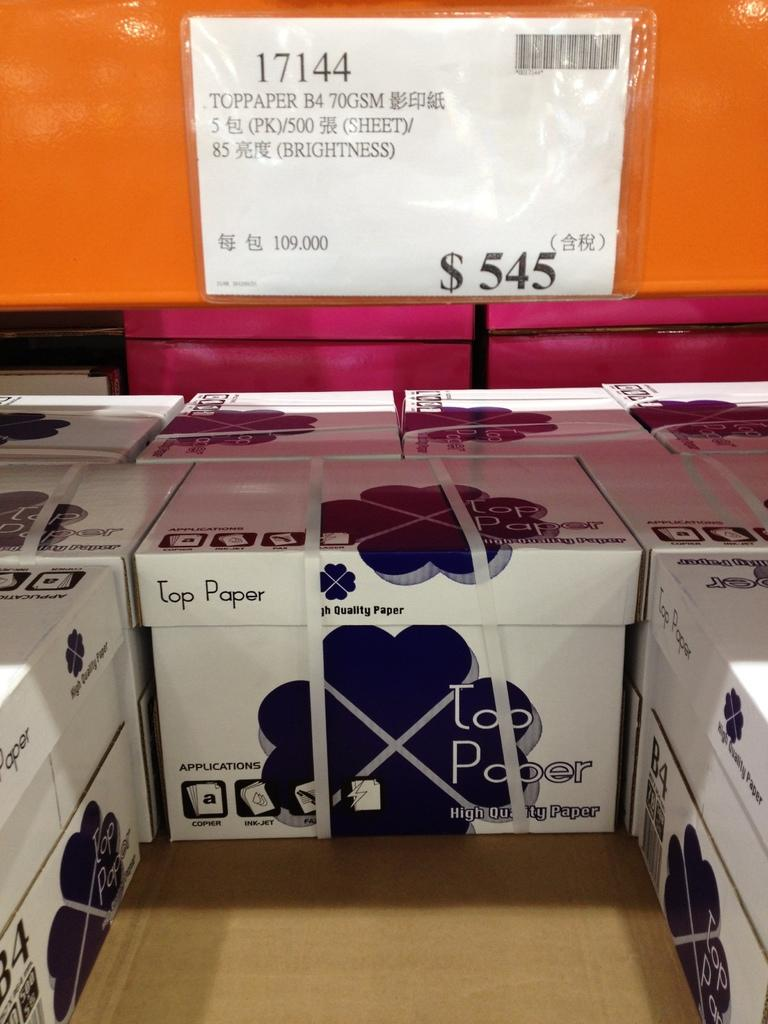Provide a one-sentence caption for the provided image. Boxes of Top Paper that each cost $545. 